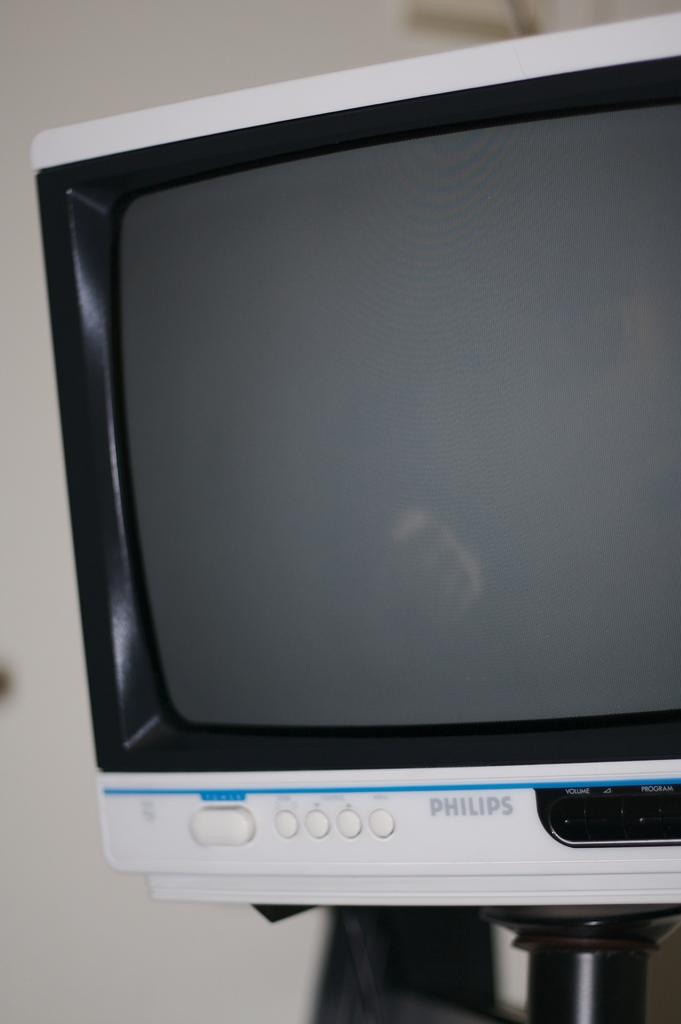<image>
Provide a brief description of the given image. A white monitor that was manufactured by Philips shows nothing on the screen. 